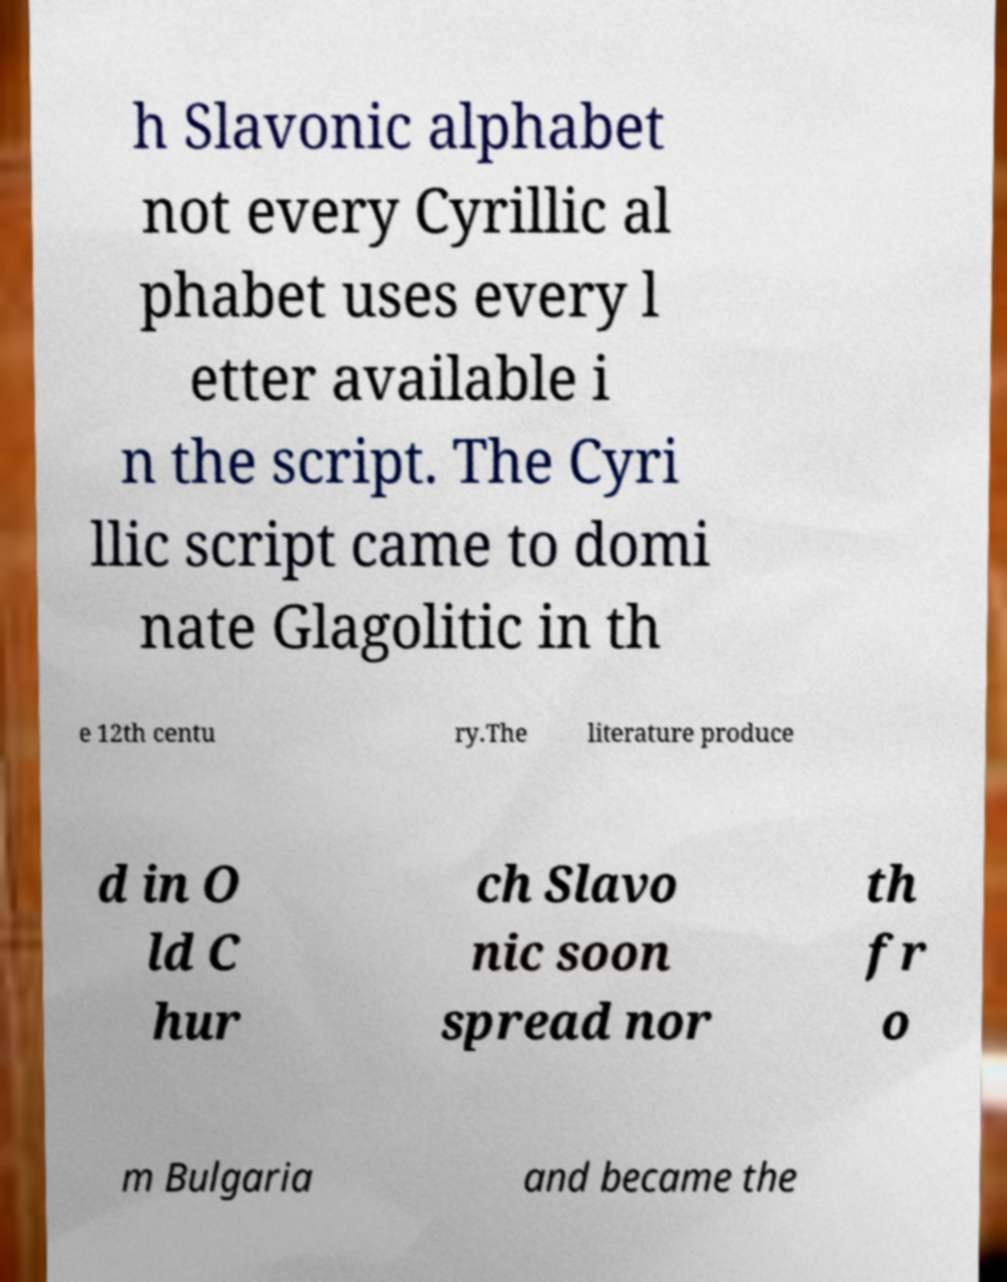Could you assist in decoding the text presented in this image and type it out clearly? h Slavonic alphabet not every Cyrillic al phabet uses every l etter available i n the script. The Cyri llic script came to domi nate Glagolitic in th e 12th centu ry.The literature produce d in O ld C hur ch Slavo nic soon spread nor th fr o m Bulgaria and became the 